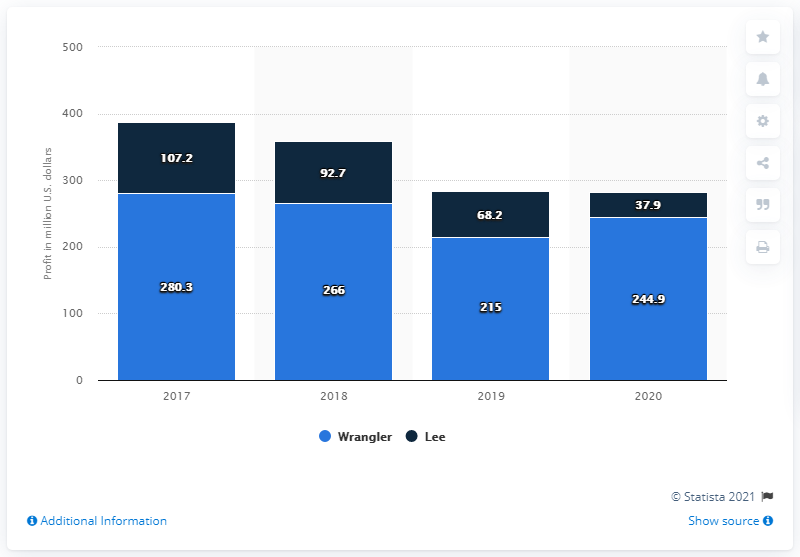Compared to Wrangler, how did Lee perform in the U.S. market in the same period? Lee's revenue performance, as illustrated in the chart, also shows a downward trend though notable differences are observed when compared to Wrangler. Starting at $107.2 million in 2017, Lee's revenue fell to $92.7 million in 2018, continued to decrease to $68.2 million in 2019, and dipped further to $37.9 million in 2020. 